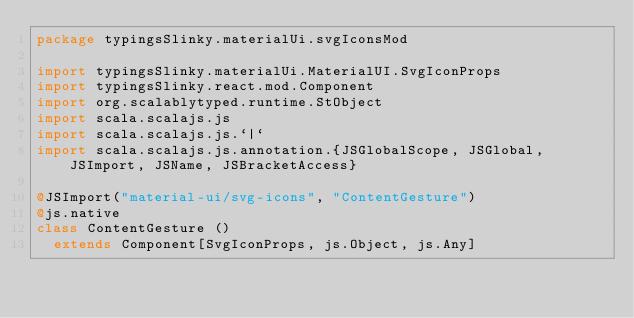<code> <loc_0><loc_0><loc_500><loc_500><_Scala_>package typingsSlinky.materialUi.svgIconsMod

import typingsSlinky.materialUi.MaterialUI.SvgIconProps
import typingsSlinky.react.mod.Component
import org.scalablytyped.runtime.StObject
import scala.scalajs.js
import scala.scalajs.js.`|`
import scala.scalajs.js.annotation.{JSGlobalScope, JSGlobal, JSImport, JSName, JSBracketAccess}

@JSImport("material-ui/svg-icons", "ContentGesture")
@js.native
class ContentGesture ()
  extends Component[SvgIconProps, js.Object, js.Any]
</code> 